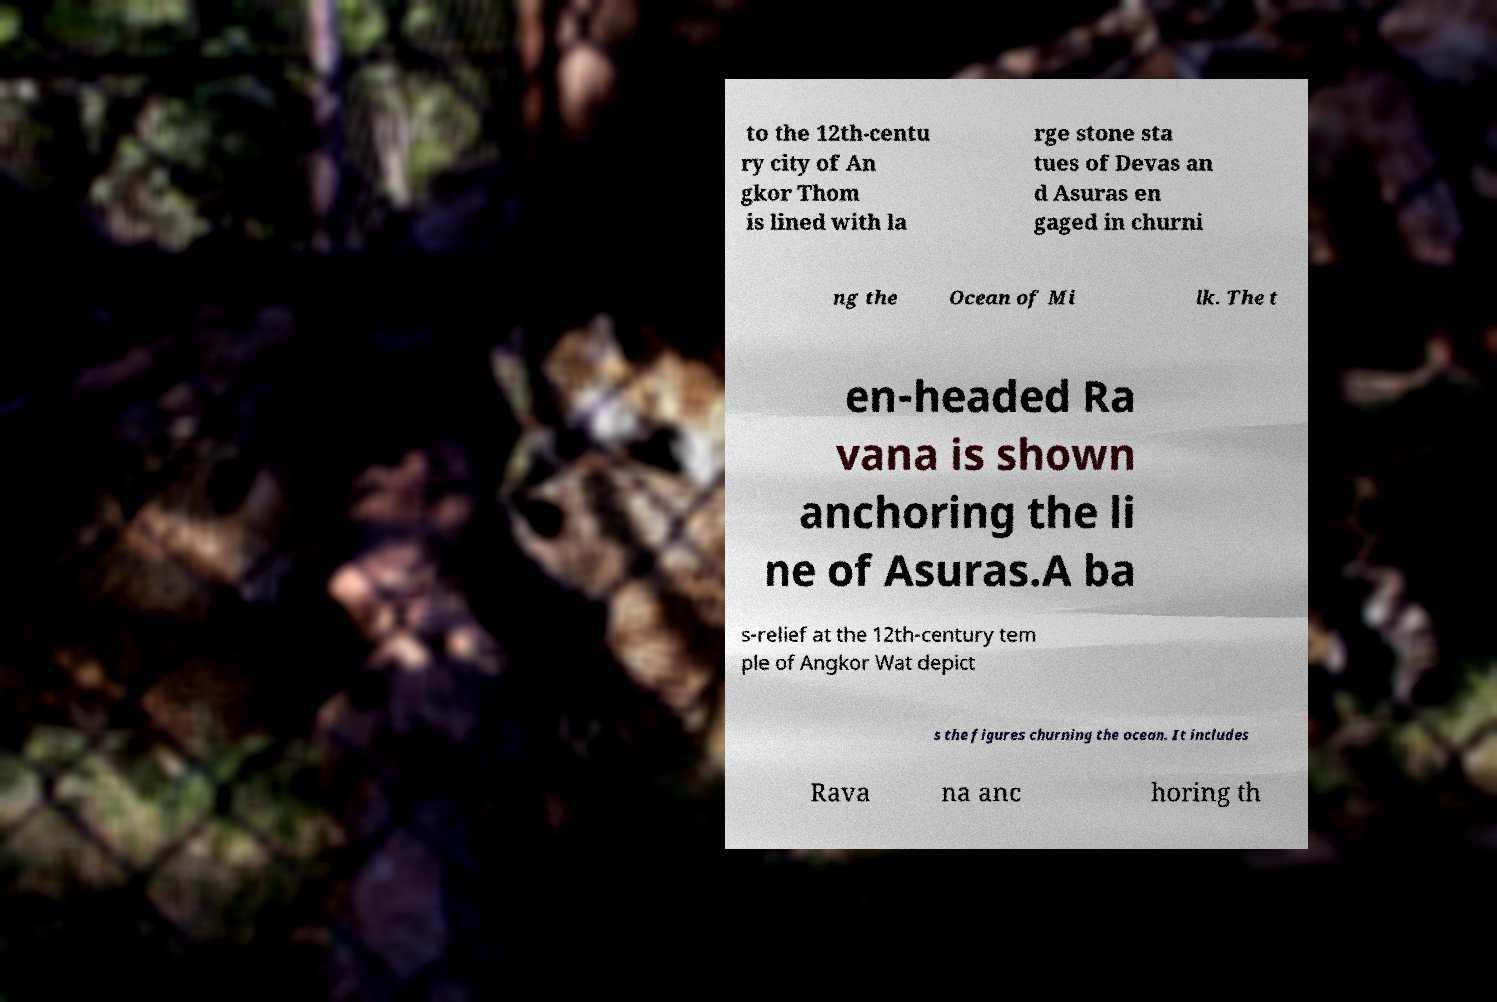Please identify and transcribe the text found in this image. to the 12th-centu ry city of An gkor Thom is lined with la rge stone sta tues of Devas an d Asuras en gaged in churni ng the Ocean of Mi lk. The t en-headed Ra vana is shown anchoring the li ne of Asuras.A ba s-relief at the 12th-century tem ple of Angkor Wat depict s the figures churning the ocean. It includes Rava na anc horing th 